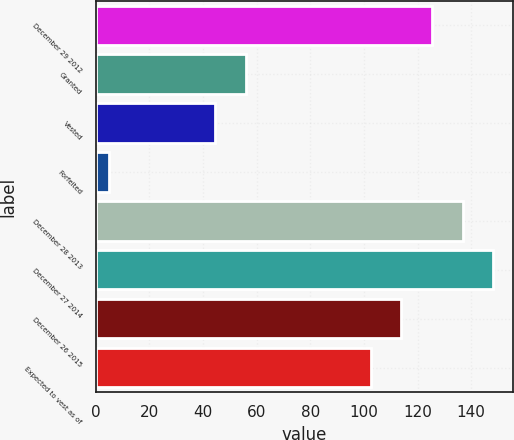Convert chart. <chart><loc_0><loc_0><loc_500><loc_500><bar_chart><fcel>December 29 2012<fcel>Granted<fcel>Vested<fcel>Forfeited<fcel>December 28 2013<fcel>December 27 2014<fcel>December 26 2015<fcel>Expected to vest as of<nl><fcel>125.4<fcel>55.95<fcel>44.5<fcel>4.9<fcel>136.85<fcel>148.3<fcel>113.95<fcel>102.5<nl></chart> 